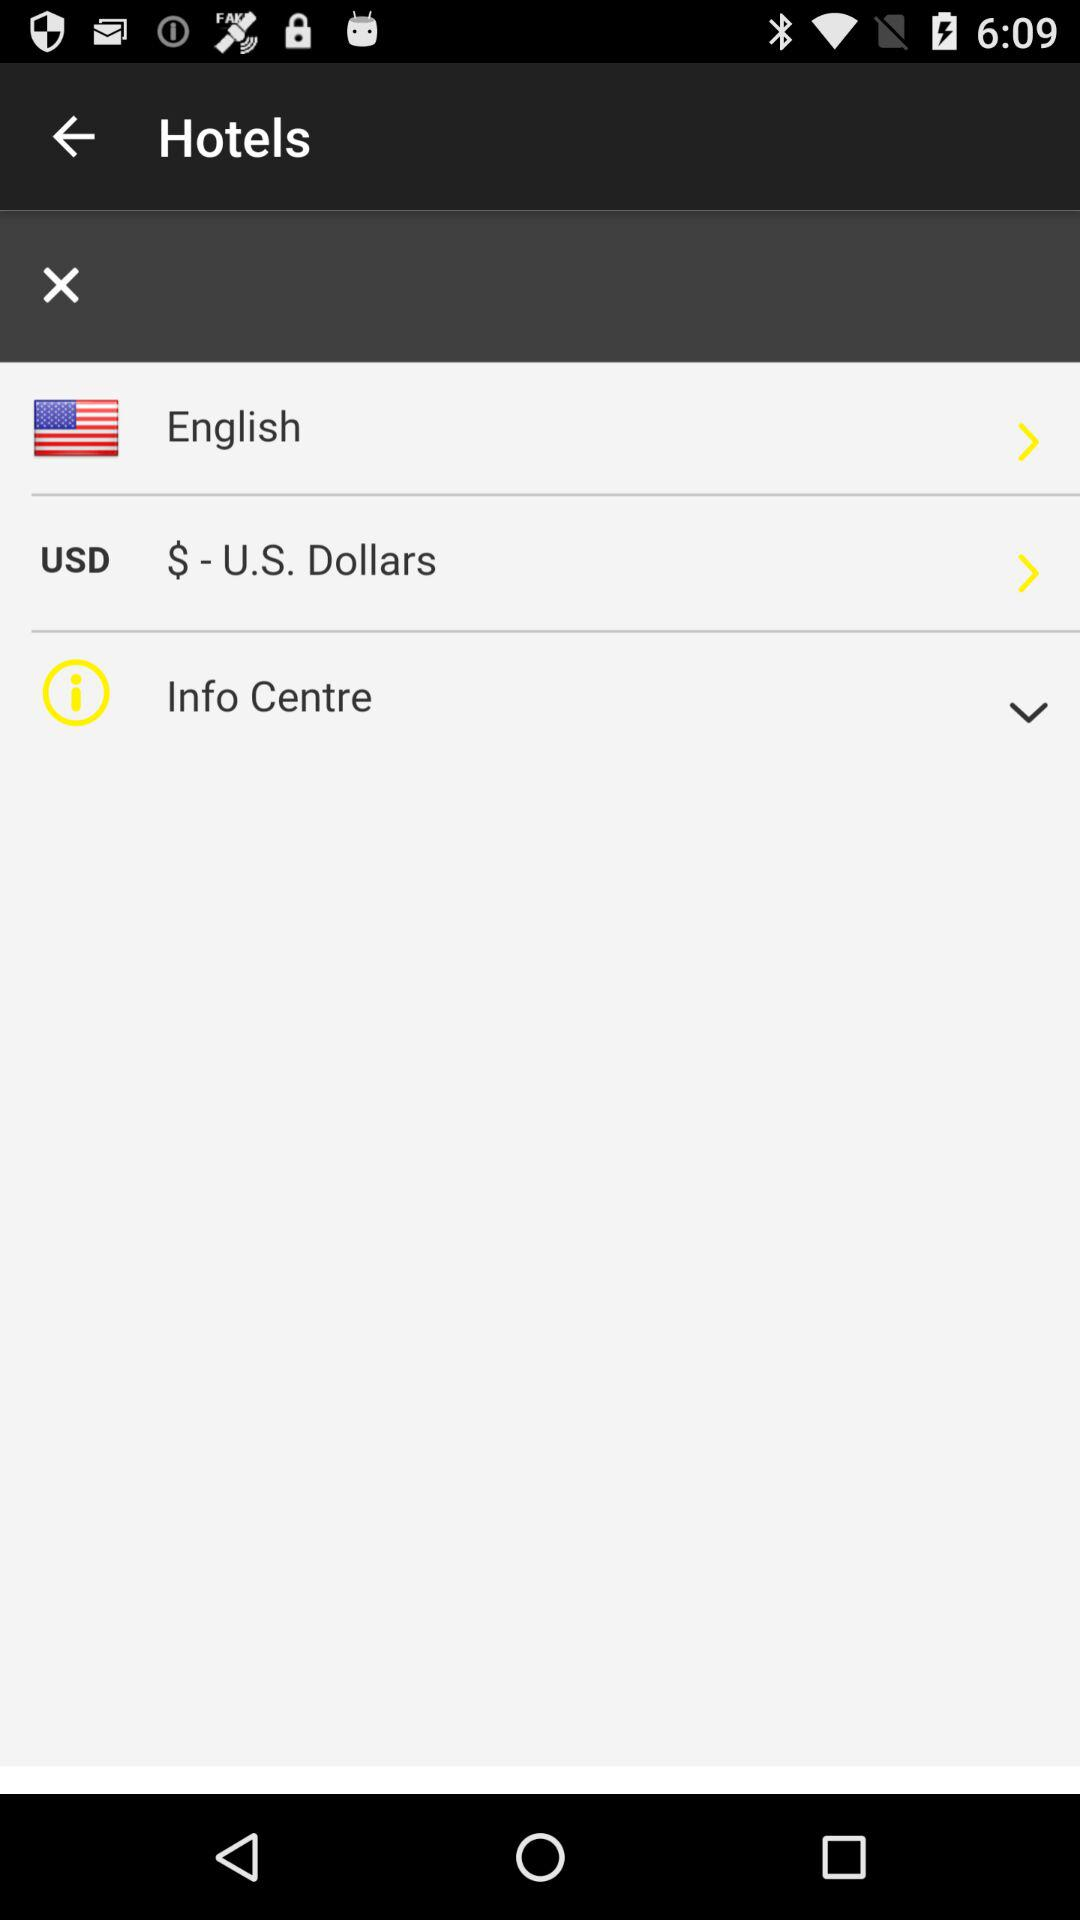What currency is shown on the screen? The currency shown on the screen is U.S. dollars. 